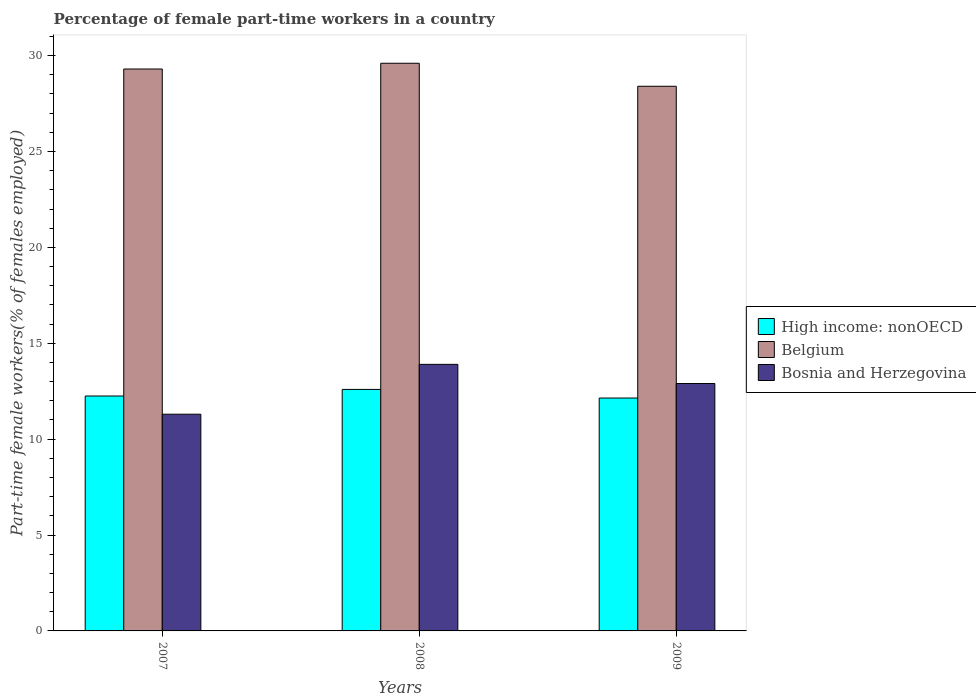How many groups of bars are there?
Make the answer very short. 3. Are the number of bars per tick equal to the number of legend labels?
Ensure brevity in your answer.  Yes. How many bars are there on the 3rd tick from the right?
Offer a terse response. 3. What is the label of the 1st group of bars from the left?
Ensure brevity in your answer.  2007. What is the percentage of female part-time workers in Bosnia and Herzegovina in 2008?
Offer a terse response. 13.9. Across all years, what is the maximum percentage of female part-time workers in High income: nonOECD?
Offer a very short reply. 12.59. Across all years, what is the minimum percentage of female part-time workers in Bosnia and Herzegovina?
Offer a very short reply. 11.3. In which year was the percentage of female part-time workers in High income: nonOECD minimum?
Offer a terse response. 2009. What is the total percentage of female part-time workers in Belgium in the graph?
Give a very brief answer. 87.3. What is the difference between the percentage of female part-time workers in Bosnia and Herzegovina in 2008 and that in 2009?
Provide a succinct answer. 1. What is the difference between the percentage of female part-time workers in Belgium in 2008 and the percentage of female part-time workers in Bosnia and Herzegovina in 2007?
Your answer should be compact. 18.3. What is the average percentage of female part-time workers in High income: nonOECD per year?
Offer a very short reply. 12.33. In the year 2007, what is the difference between the percentage of female part-time workers in High income: nonOECD and percentage of female part-time workers in Bosnia and Herzegovina?
Provide a succinct answer. 0.95. In how many years, is the percentage of female part-time workers in Bosnia and Herzegovina greater than 21 %?
Your answer should be very brief. 0. What is the ratio of the percentage of female part-time workers in Bosnia and Herzegovina in 2007 to that in 2008?
Ensure brevity in your answer.  0.81. Is the percentage of female part-time workers in Bosnia and Herzegovina in 2008 less than that in 2009?
Offer a terse response. No. Is the difference between the percentage of female part-time workers in High income: nonOECD in 2007 and 2009 greater than the difference between the percentage of female part-time workers in Bosnia and Herzegovina in 2007 and 2009?
Make the answer very short. Yes. What is the difference between the highest and the second highest percentage of female part-time workers in High income: nonOECD?
Give a very brief answer. 0.34. What is the difference between the highest and the lowest percentage of female part-time workers in Bosnia and Herzegovina?
Your response must be concise. 2.6. Is the sum of the percentage of female part-time workers in Belgium in 2007 and 2008 greater than the maximum percentage of female part-time workers in High income: nonOECD across all years?
Your answer should be compact. Yes. What does the 3rd bar from the left in 2009 represents?
Offer a very short reply. Bosnia and Herzegovina. How many bars are there?
Ensure brevity in your answer.  9. Are all the bars in the graph horizontal?
Provide a short and direct response. No. Are the values on the major ticks of Y-axis written in scientific E-notation?
Offer a very short reply. No. Does the graph contain any zero values?
Ensure brevity in your answer.  No. Does the graph contain grids?
Keep it short and to the point. No. Where does the legend appear in the graph?
Offer a very short reply. Center right. How are the legend labels stacked?
Offer a very short reply. Vertical. What is the title of the graph?
Provide a succinct answer. Percentage of female part-time workers in a country. Does "Cameroon" appear as one of the legend labels in the graph?
Your answer should be very brief. No. What is the label or title of the Y-axis?
Your answer should be very brief. Part-time female workers(% of females employed). What is the Part-time female workers(% of females employed) in High income: nonOECD in 2007?
Make the answer very short. 12.25. What is the Part-time female workers(% of females employed) in Belgium in 2007?
Keep it short and to the point. 29.3. What is the Part-time female workers(% of females employed) of Bosnia and Herzegovina in 2007?
Ensure brevity in your answer.  11.3. What is the Part-time female workers(% of females employed) in High income: nonOECD in 2008?
Make the answer very short. 12.59. What is the Part-time female workers(% of females employed) of Belgium in 2008?
Provide a succinct answer. 29.6. What is the Part-time female workers(% of females employed) of Bosnia and Herzegovina in 2008?
Provide a succinct answer. 13.9. What is the Part-time female workers(% of females employed) in High income: nonOECD in 2009?
Provide a short and direct response. 12.14. What is the Part-time female workers(% of females employed) of Belgium in 2009?
Provide a succinct answer. 28.4. What is the Part-time female workers(% of females employed) of Bosnia and Herzegovina in 2009?
Your answer should be very brief. 12.9. Across all years, what is the maximum Part-time female workers(% of females employed) of High income: nonOECD?
Make the answer very short. 12.59. Across all years, what is the maximum Part-time female workers(% of females employed) of Belgium?
Your answer should be compact. 29.6. Across all years, what is the maximum Part-time female workers(% of females employed) in Bosnia and Herzegovina?
Provide a short and direct response. 13.9. Across all years, what is the minimum Part-time female workers(% of females employed) in High income: nonOECD?
Your answer should be very brief. 12.14. Across all years, what is the minimum Part-time female workers(% of females employed) of Belgium?
Make the answer very short. 28.4. Across all years, what is the minimum Part-time female workers(% of females employed) in Bosnia and Herzegovina?
Make the answer very short. 11.3. What is the total Part-time female workers(% of females employed) in High income: nonOECD in the graph?
Your answer should be compact. 36.99. What is the total Part-time female workers(% of females employed) of Belgium in the graph?
Make the answer very short. 87.3. What is the total Part-time female workers(% of females employed) in Bosnia and Herzegovina in the graph?
Your answer should be very brief. 38.1. What is the difference between the Part-time female workers(% of females employed) in High income: nonOECD in 2007 and that in 2008?
Offer a very short reply. -0.34. What is the difference between the Part-time female workers(% of females employed) of Bosnia and Herzegovina in 2007 and that in 2008?
Provide a short and direct response. -2.6. What is the difference between the Part-time female workers(% of females employed) in High income: nonOECD in 2007 and that in 2009?
Your response must be concise. 0.11. What is the difference between the Part-time female workers(% of females employed) in Belgium in 2007 and that in 2009?
Your answer should be compact. 0.9. What is the difference between the Part-time female workers(% of females employed) of Bosnia and Herzegovina in 2007 and that in 2009?
Make the answer very short. -1.6. What is the difference between the Part-time female workers(% of females employed) of High income: nonOECD in 2008 and that in 2009?
Your response must be concise. 0.45. What is the difference between the Part-time female workers(% of females employed) in High income: nonOECD in 2007 and the Part-time female workers(% of females employed) in Belgium in 2008?
Offer a terse response. -17.35. What is the difference between the Part-time female workers(% of females employed) in High income: nonOECD in 2007 and the Part-time female workers(% of females employed) in Bosnia and Herzegovina in 2008?
Give a very brief answer. -1.65. What is the difference between the Part-time female workers(% of females employed) in Belgium in 2007 and the Part-time female workers(% of females employed) in Bosnia and Herzegovina in 2008?
Offer a very short reply. 15.4. What is the difference between the Part-time female workers(% of females employed) of High income: nonOECD in 2007 and the Part-time female workers(% of females employed) of Belgium in 2009?
Offer a terse response. -16.15. What is the difference between the Part-time female workers(% of females employed) in High income: nonOECD in 2007 and the Part-time female workers(% of females employed) in Bosnia and Herzegovina in 2009?
Give a very brief answer. -0.65. What is the difference between the Part-time female workers(% of females employed) in Belgium in 2007 and the Part-time female workers(% of females employed) in Bosnia and Herzegovina in 2009?
Keep it short and to the point. 16.4. What is the difference between the Part-time female workers(% of females employed) in High income: nonOECD in 2008 and the Part-time female workers(% of females employed) in Belgium in 2009?
Provide a succinct answer. -15.81. What is the difference between the Part-time female workers(% of females employed) of High income: nonOECD in 2008 and the Part-time female workers(% of females employed) of Bosnia and Herzegovina in 2009?
Make the answer very short. -0.31. What is the difference between the Part-time female workers(% of females employed) in Belgium in 2008 and the Part-time female workers(% of females employed) in Bosnia and Herzegovina in 2009?
Offer a very short reply. 16.7. What is the average Part-time female workers(% of females employed) in High income: nonOECD per year?
Ensure brevity in your answer.  12.33. What is the average Part-time female workers(% of females employed) in Belgium per year?
Give a very brief answer. 29.1. In the year 2007, what is the difference between the Part-time female workers(% of females employed) of High income: nonOECD and Part-time female workers(% of females employed) of Belgium?
Make the answer very short. -17.05. In the year 2007, what is the difference between the Part-time female workers(% of females employed) of High income: nonOECD and Part-time female workers(% of females employed) of Bosnia and Herzegovina?
Your answer should be very brief. 0.95. In the year 2008, what is the difference between the Part-time female workers(% of females employed) in High income: nonOECD and Part-time female workers(% of females employed) in Belgium?
Give a very brief answer. -17.01. In the year 2008, what is the difference between the Part-time female workers(% of females employed) in High income: nonOECD and Part-time female workers(% of females employed) in Bosnia and Herzegovina?
Your answer should be very brief. -1.31. In the year 2008, what is the difference between the Part-time female workers(% of females employed) of Belgium and Part-time female workers(% of females employed) of Bosnia and Herzegovina?
Your response must be concise. 15.7. In the year 2009, what is the difference between the Part-time female workers(% of females employed) of High income: nonOECD and Part-time female workers(% of females employed) of Belgium?
Offer a very short reply. -16.26. In the year 2009, what is the difference between the Part-time female workers(% of females employed) in High income: nonOECD and Part-time female workers(% of females employed) in Bosnia and Herzegovina?
Your answer should be very brief. -0.76. What is the ratio of the Part-time female workers(% of females employed) of High income: nonOECD in 2007 to that in 2008?
Your answer should be very brief. 0.97. What is the ratio of the Part-time female workers(% of females employed) of Bosnia and Herzegovina in 2007 to that in 2008?
Ensure brevity in your answer.  0.81. What is the ratio of the Part-time female workers(% of females employed) in High income: nonOECD in 2007 to that in 2009?
Give a very brief answer. 1.01. What is the ratio of the Part-time female workers(% of females employed) of Belgium in 2007 to that in 2009?
Offer a terse response. 1.03. What is the ratio of the Part-time female workers(% of females employed) of Bosnia and Herzegovina in 2007 to that in 2009?
Offer a terse response. 0.88. What is the ratio of the Part-time female workers(% of females employed) in High income: nonOECD in 2008 to that in 2009?
Offer a very short reply. 1.04. What is the ratio of the Part-time female workers(% of females employed) in Belgium in 2008 to that in 2009?
Offer a terse response. 1.04. What is the ratio of the Part-time female workers(% of females employed) in Bosnia and Herzegovina in 2008 to that in 2009?
Your answer should be compact. 1.08. What is the difference between the highest and the second highest Part-time female workers(% of females employed) of High income: nonOECD?
Your response must be concise. 0.34. What is the difference between the highest and the second highest Part-time female workers(% of females employed) in Bosnia and Herzegovina?
Give a very brief answer. 1. What is the difference between the highest and the lowest Part-time female workers(% of females employed) of High income: nonOECD?
Your answer should be compact. 0.45. What is the difference between the highest and the lowest Part-time female workers(% of females employed) of Bosnia and Herzegovina?
Keep it short and to the point. 2.6. 